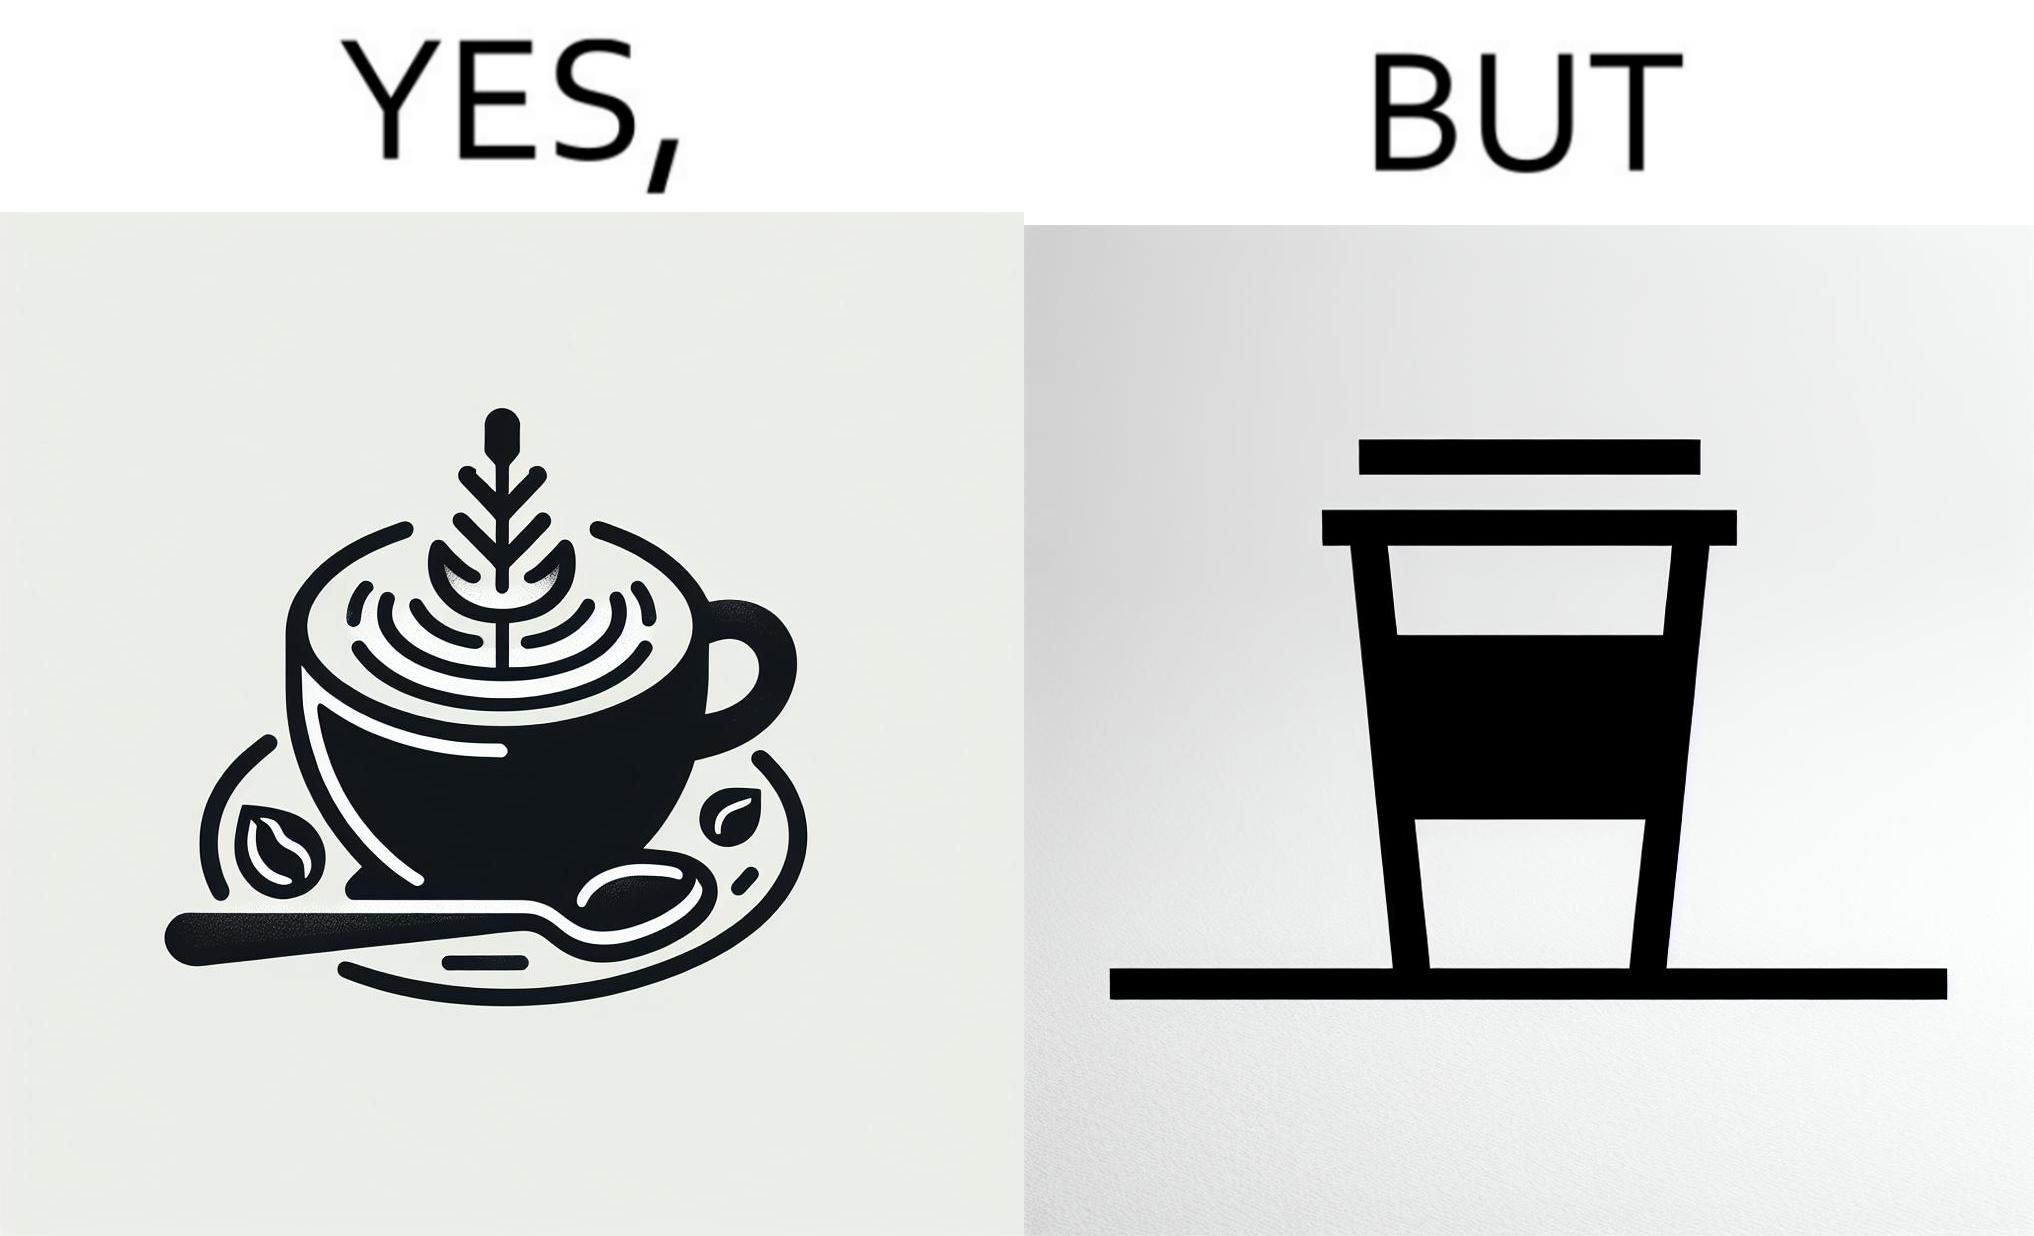Provide a description of this image. The images are funny since it shows how someone has put effort into a cup of coffee to do latte art on it only for it to be invisible after a lid is put on the coffee cup before serving to a customer 